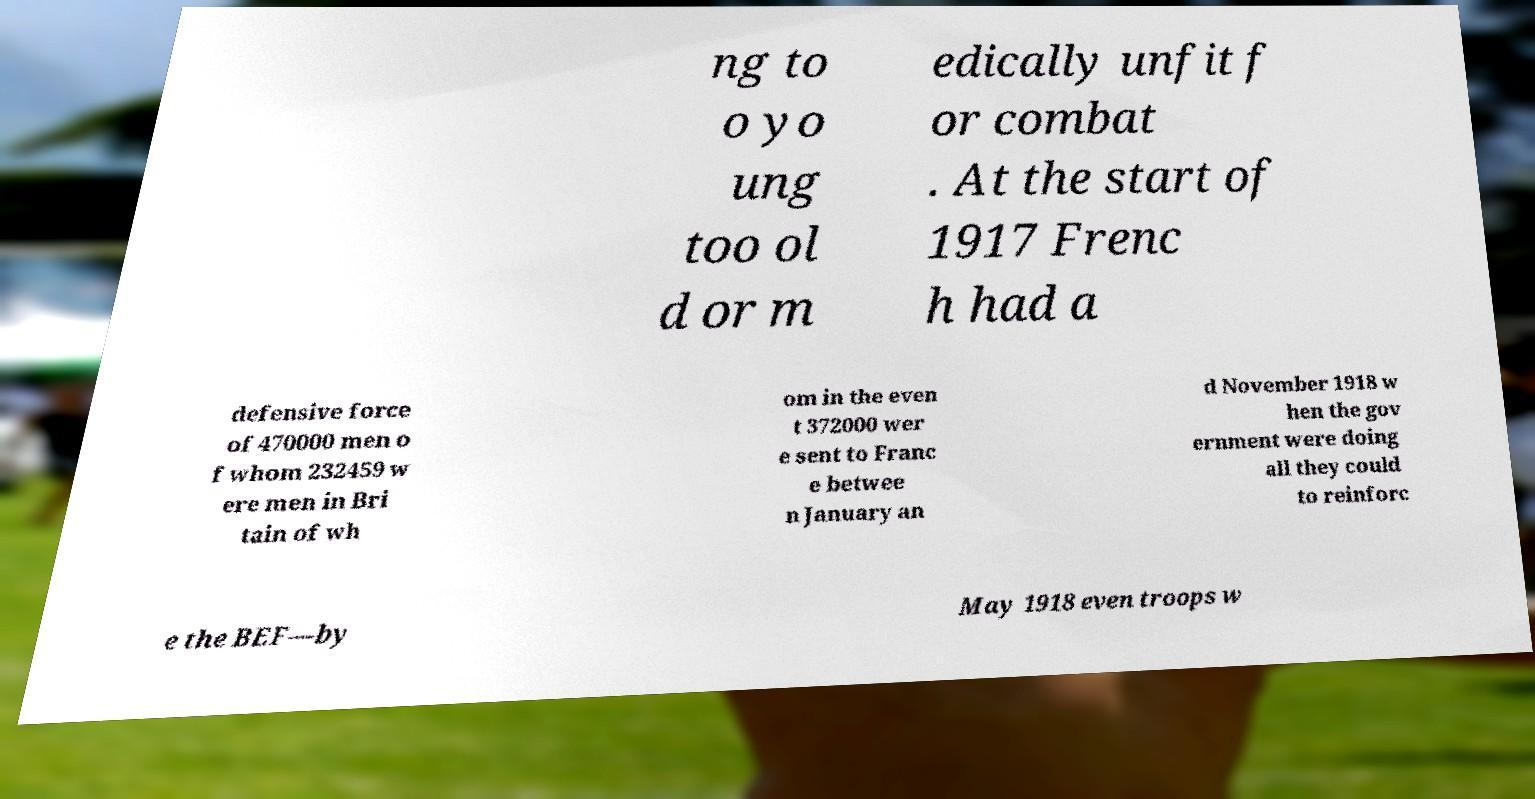Could you extract and type out the text from this image? ng to o yo ung too ol d or m edically unfit f or combat . At the start of 1917 Frenc h had a defensive force of 470000 men o f whom 232459 w ere men in Bri tain of wh om in the even t 372000 wer e sent to Franc e betwee n January an d November 1918 w hen the gov ernment were doing all they could to reinforc e the BEF—by May 1918 even troops w 